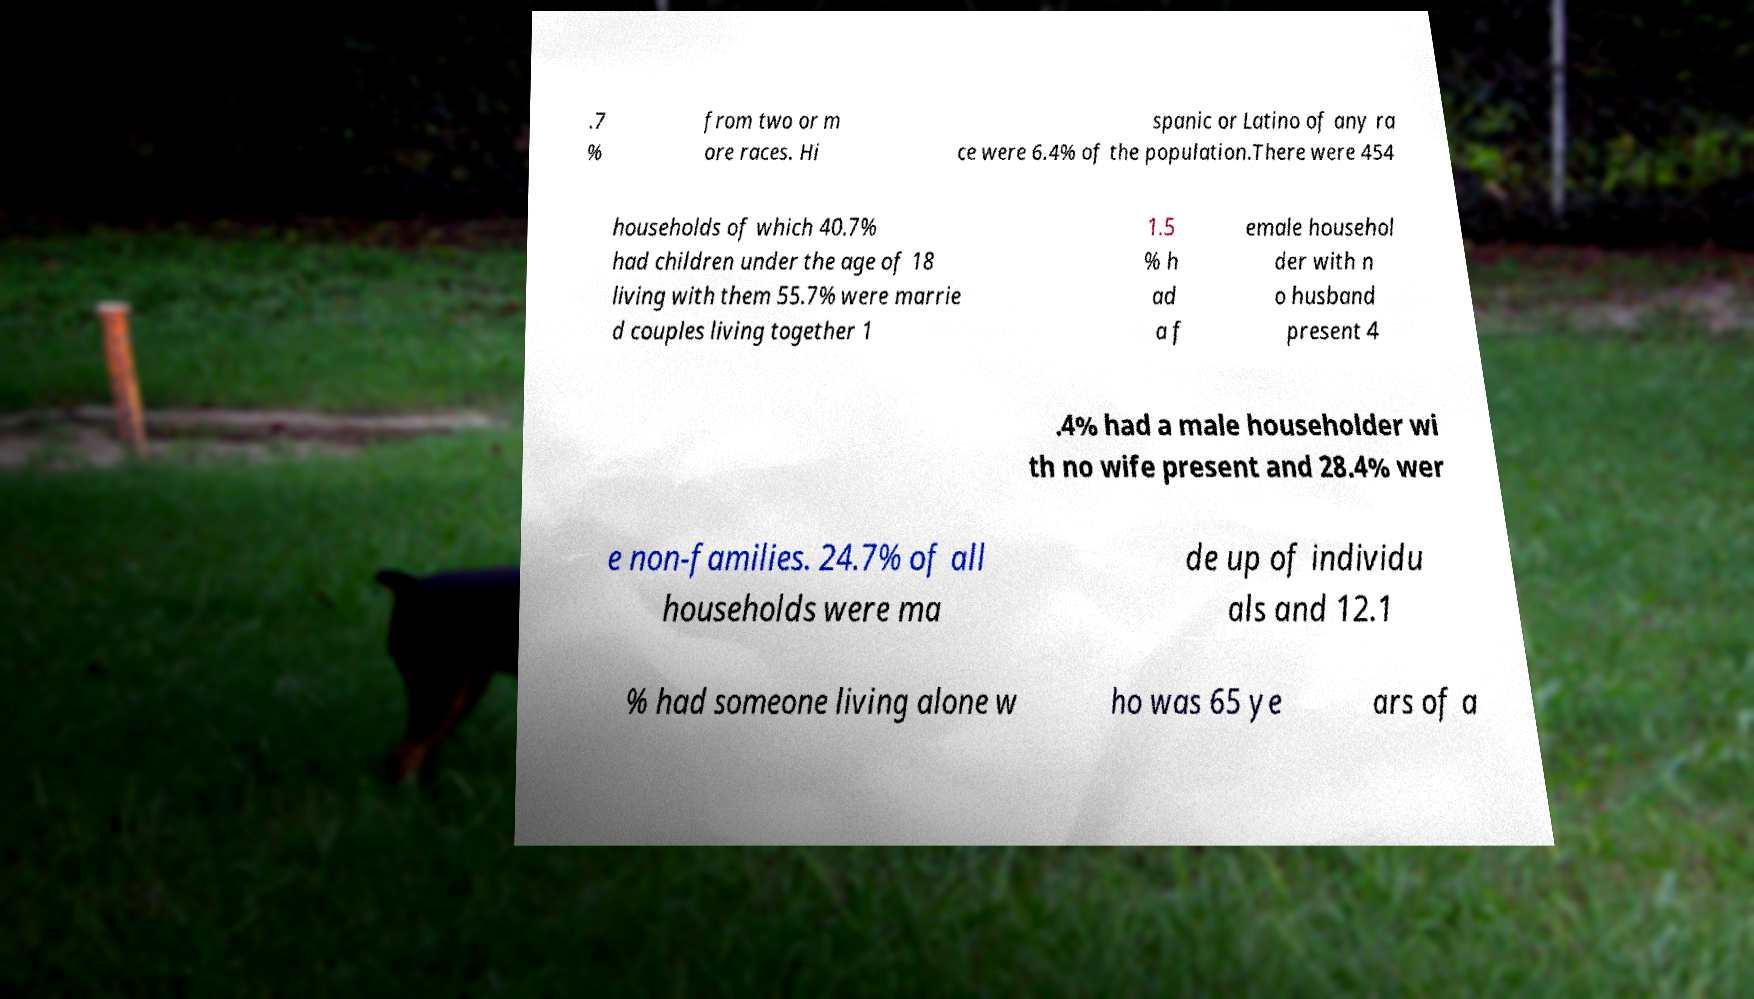Can you accurately transcribe the text from the provided image for me? .7 % from two or m ore races. Hi spanic or Latino of any ra ce were 6.4% of the population.There were 454 households of which 40.7% had children under the age of 18 living with them 55.7% were marrie d couples living together 1 1.5 % h ad a f emale househol der with n o husband present 4 .4% had a male householder wi th no wife present and 28.4% wer e non-families. 24.7% of all households were ma de up of individu als and 12.1 % had someone living alone w ho was 65 ye ars of a 